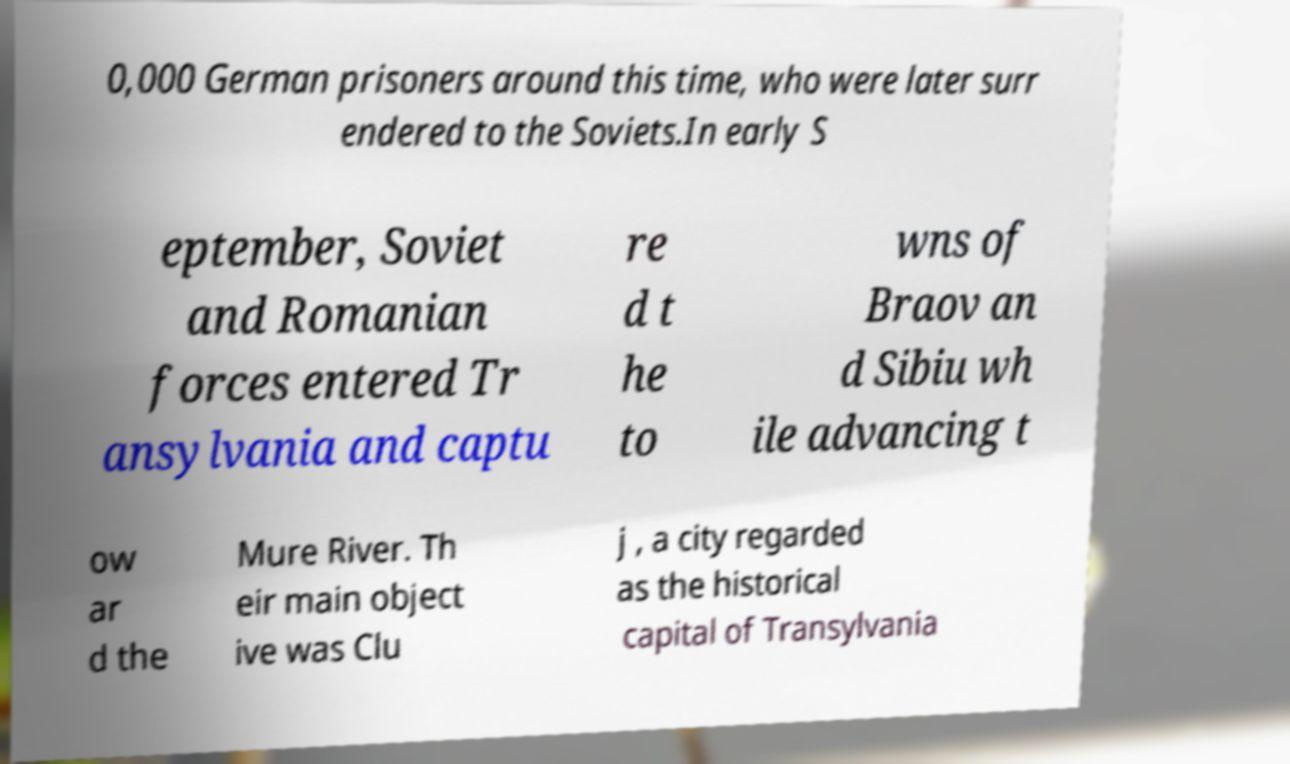Please identify and transcribe the text found in this image. 0,000 German prisoners around this time, who were later surr endered to the Soviets.In early S eptember, Soviet and Romanian forces entered Tr ansylvania and captu re d t he to wns of Braov an d Sibiu wh ile advancing t ow ar d the Mure River. Th eir main object ive was Clu j , a city regarded as the historical capital of Transylvania 